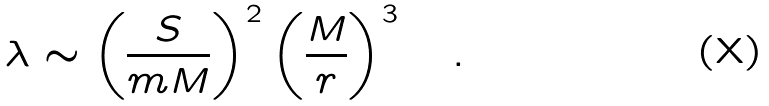<formula> <loc_0><loc_0><loc_500><loc_500>\lambda \sim \left ( \frac { S } { m M } \right ) ^ { 2 } \left ( \frac { M } { r } \right ) ^ { 3 } \quad .</formula> 